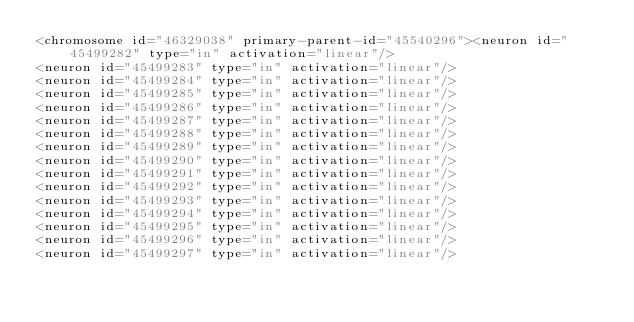Convert code to text. <code><loc_0><loc_0><loc_500><loc_500><_XML_><chromosome id="46329038" primary-parent-id="45540296"><neuron id="45499282" type="in" activation="linear"/>
<neuron id="45499283" type="in" activation="linear"/>
<neuron id="45499284" type="in" activation="linear"/>
<neuron id="45499285" type="in" activation="linear"/>
<neuron id="45499286" type="in" activation="linear"/>
<neuron id="45499287" type="in" activation="linear"/>
<neuron id="45499288" type="in" activation="linear"/>
<neuron id="45499289" type="in" activation="linear"/>
<neuron id="45499290" type="in" activation="linear"/>
<neuron id="45499291" type="in" activation="linear"/>
<neuron id="45499292" type="in" activation="linear"/>
<neuron id="45499293" type="in" activation="linear"/>
<neuron id="45499294" type="in" activation="linear"/>
<neuron id="45499295" type="in" activation="linear"/>
<neuron id="45499296" type="in" activation="linear"/>
<neuron id="45499297" type="in" activation="linear"/></code> 